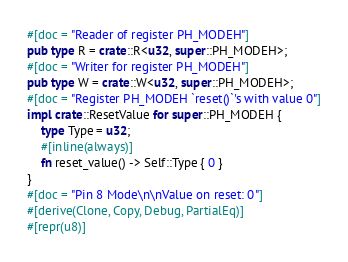<code> <loc_0><loc_0><loc_500><loc_500><_Rust_>#[doc = "Reader of register PH_MODEH"]
pub type R = crate::R<u32, super::PH_MODEH>;
#[doc = "Writer for register PH_MODEH"]
pub type W = crate::W<u32, super::PH_MODEH>;
#[doc = "Register PH_MODEH `reset()`'s with value 0"]
impl crate::ResetValue for super::PH_MODEH {
    type Type = u32;
    #[inline(always)]
    fn reset_value() -> Self::Type { 0 }
}
#[doc = "Pin 8 Mode\n\nValue on reset: 0"]
#[derive(Clone, Copy, Debug, PartialEq)]
#[repr(u8)]</code> 